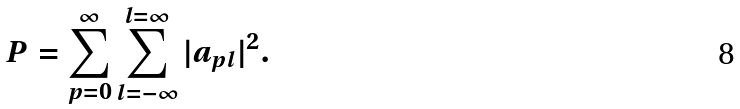<formula> <loc_0><loc_0><loc_500><loc_500>P = \sum _ { p = 0 } ^ { \infty } \sum _ { l = - \infty } ^ { l = \infty } | a _ { p l } | ^ { 2 } .</formula> 